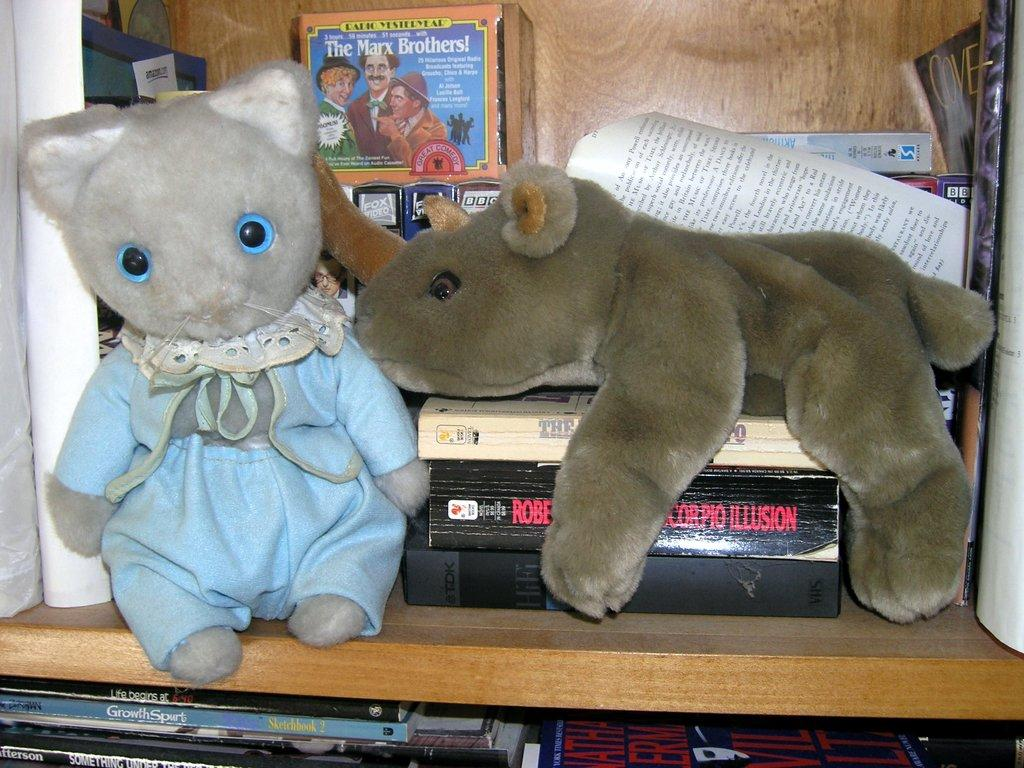What is the person holding in the image? The person is holding a camera in the image. What is the person standing near in the image? The person is standing near a tripod in the image. What can be seen in the background of the image? There is a building in the background of the image. What type of pig can be seen in the person's pocket in the image? There is no pig present in the image, nor is there any mention of a pocket. --- What is the person doing in the image? The person is sitting on a chair and reading a book in the image. What is in front of the person in the image? There is a table in front of the person in the image. Reasoning: Let's think step by step in order to produce the conversation. We start by identifying the main subject in the image, which is the person sitting on a chair. Then, we mention the activity the person is engaged in, which is reading a book. Finally, we describe the table that is in front of the person. Absurd Question/Answer: What type of insect can be seen crawling on the person's forehead in the image? There is no insect present in the image, nor is there any mention of a forehead. --- What is the person standing near in the image? The person is standing near a car in the image. What is in front of the car in the image? There is a house in front of the car in the image. Reasoning: Let's think step by step in order to produce the conversation. We start by identifying the main subject in the image, which is the person standing near a car. Then, we mention the car's location, which is in front of a house. Absurd Question/Answer: What type of pocket can be seen on the car's hood in the image? There is no pocket present in the image, nor is there any mention of a hood. --- What is on the table in the image? On the table in the image, there are plates, cups, and food. How many people are in the image? There is a group of people in the image. Reasoning: Let's think step by step in order to produce the conversation. We start by identifying the main subject in the image, which is the table with plates, cups, and food. Then, we mention the group of people who are standing near the table. Absurd Question/Answer: What type of pig can be seen flying over the table in the image? There is no pig present in the image, nor is there any mention of flying. 